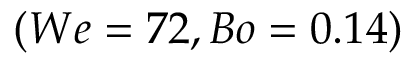<formula> <loc_0><loc_0><loc_500><loc_500>( W e = 7 2 , B o = 0 . 1 4 )</formula> 